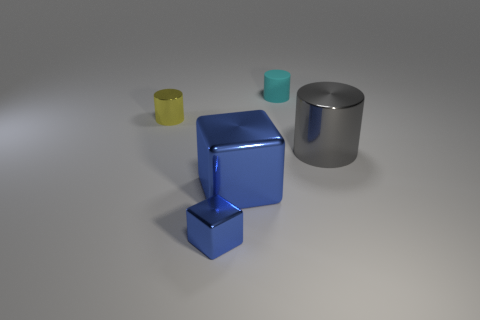What material is the cyan cylinder?
Your answer should be very brief. Rubber. How many other things are the same material as the gray object?
Make the answer very short. 3. What number of large purple rubber balls are there?
Your answer should be compact. 0. There is a small yellow object that is the same shape as the tiny cyan matte object; what is it made of?
Make the answer very short. Metal. Is the small cylinder in front of the small cyan cylinder made of the same material as the big cylinder?
Offer a terse response. Yes. Are there more small blue shiny cubes in front of the yellow thing than big metal cylinders in front of the tiny blue thing?
Ensure brevity in your answer.  Yes. What is the size of the rubber cylinder?
Make the answer very short. Small. There is a yellow object that is the same material as the large blue cube; what is its shape?
Ensure brevity in your answer.  Cylinder. There is a small thing that is behind the tiny metal cylinder; is it the same shape as the large gray metallic thing?
Make the answer very short. Yes. How many things are either purple metallic cubes or large things?
Give a very brief answer. 2. 